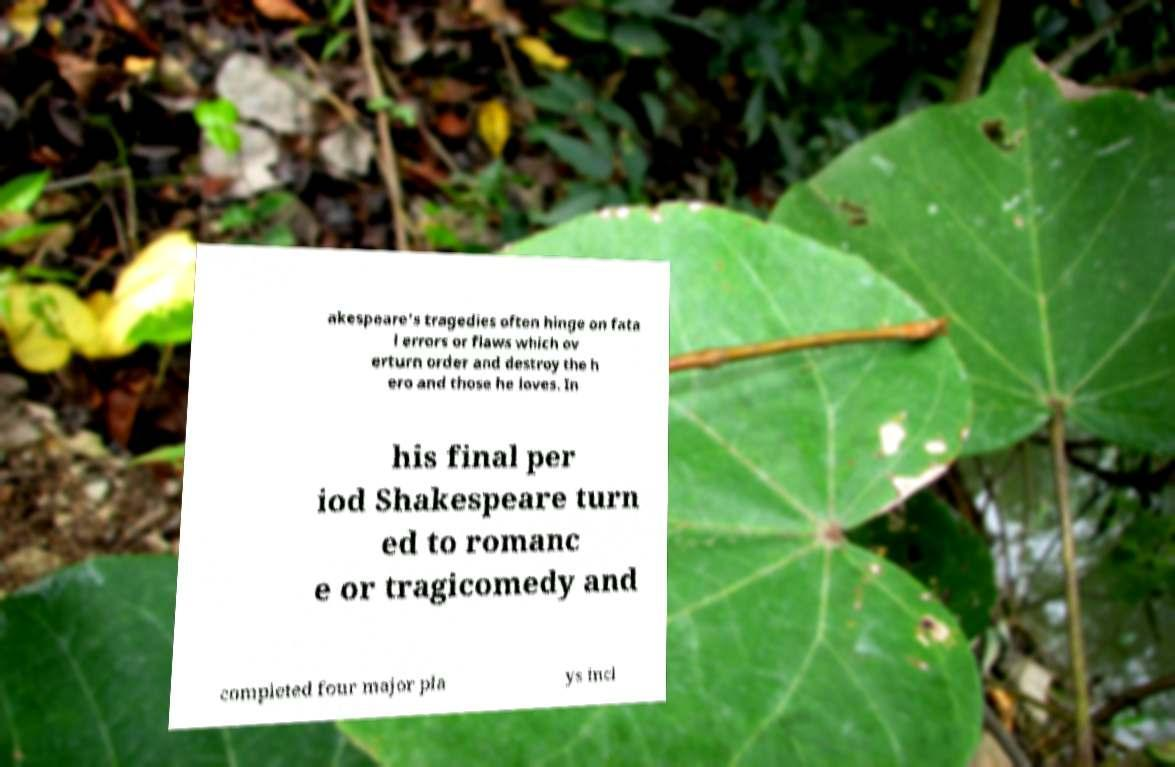Could you extract and type out the text from this image? akespeare's tragedies often hinge on fata l errors or flaws which ov erturn order and destroy the h ero and those he loves. In his final per iod Shakespeare turn ed to romanc e or tragicomedy and completed four major pla ys incl 